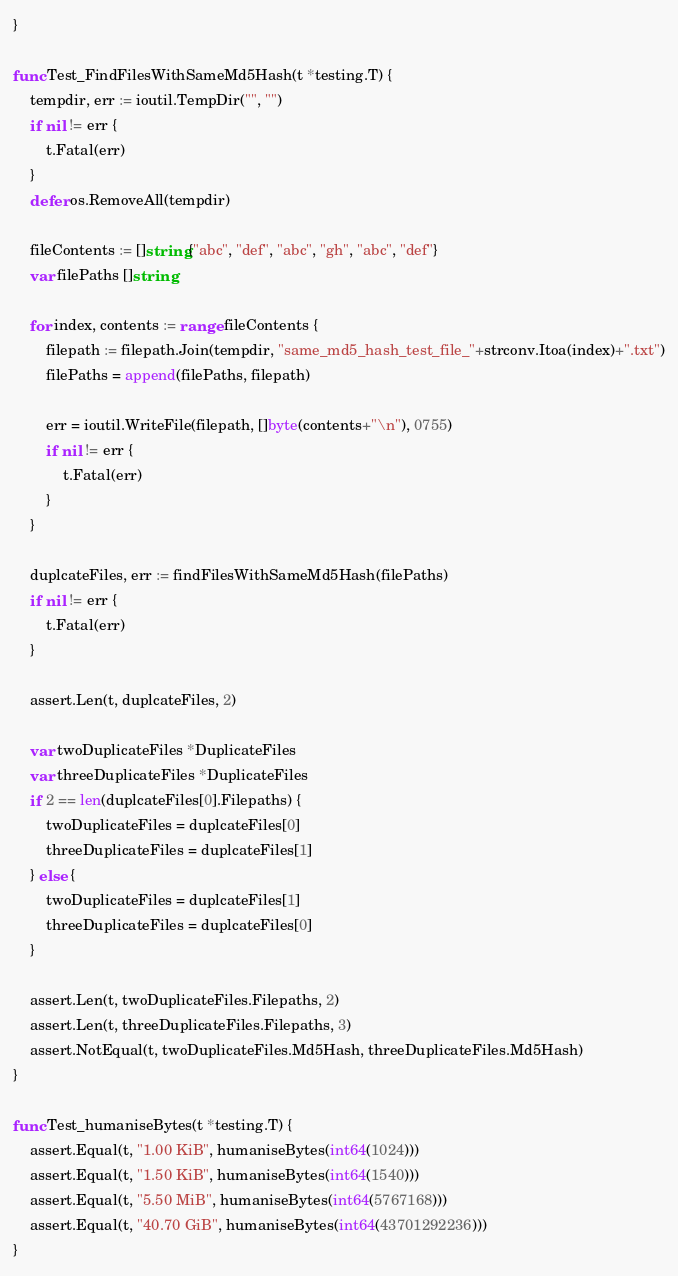Convert code to text. <code><loc_0><loc_0><loc_500><loc_500><_Go_>}

func Test_FindFilesWithSameMd5Hash(t *testing.T) {
	tempdir, err := ioutil.TempDir("", "")
	if nil != err {
		t.Fatal(err)
	}
	defer os.RemoveAll(tempdir)

	fileContents := []string{"abc", "def", "abc", "gh", "abc", "def"}
	var filePaths []string

	for index, contents := range fileContents {
		filepath := filepath.Join(tempdir, "same_md5_hash_test_file_"+strconv.Itoa(index)+".txt")
		filePaths = append(filePaths, filepath)

		err = ioutil.WriteFile(filepath, []byte(contents+"\n"), 0755)
		if nil != err {
			t.Fatal(err)
		}
	}

	duplcateFiles, err := findFilesWithSameMd5Hash(filePaths)
	if nil != err {
		t.Fatal(err)
	}

	assert.Len(t, duplcateFiles, 2)

	var twoDuplicateFiles *DuplicateFiles
	var threeDuplicateFiles *DuplicateFiles
	if 2 == len(duplcateFiles[0].Filepaths) {
		twoDuplicateFiles = duplcateFiles[0]
		threeDuplicateFiles = duplcateFiles[1]
	} else {
		twoDuplicateFiles = duplcateFiles[1]
		threeDuplicateFiles = duplcateFiles[0]
	}

	assert.Len(t, twoDuplicateFiles.Filepaths, 2)
	assert.Len(t, threeDuplicateFiles.Filepaths, 3)
	assert.NotEqual(t, twoDuplicateFiles.Md5Hash, threeDuplicateFiles.Md5Hash)
}

func Test_humaniseBytes(t *testing.T) {
	assert.Equal(t, "1.00 KiB", humaniseBytes(int64(1024)))
	assert.Equal(t, "1.50 KiB", humaniseBytes(int64(1540)))
	assert.Equal(t, "5.50 MiB", humaniseBytes(int64(5767168)))
	assert.Equal(t, "40.70 GiB", humaniseBytes(int64(43701292236)))
}
</code> 